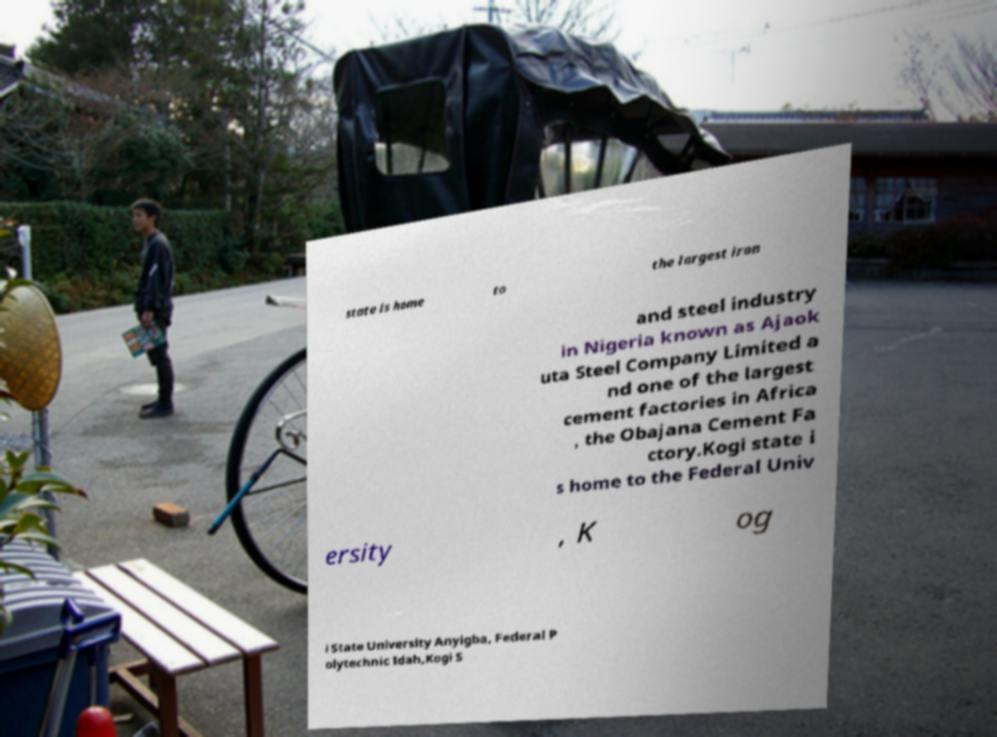Could you extract and type out the text from this image? state is home to the largest iron and steel industry in Nigeria known as Ajaok uta Steel Company Limited a nd one of the largest cement factories in Africa , the Obajana Cement Fa ctory.Kogi state i s home to the Federal Univ ersity , K og i State University Anyigba, Federal P olytechnic Idah,Kogi S 